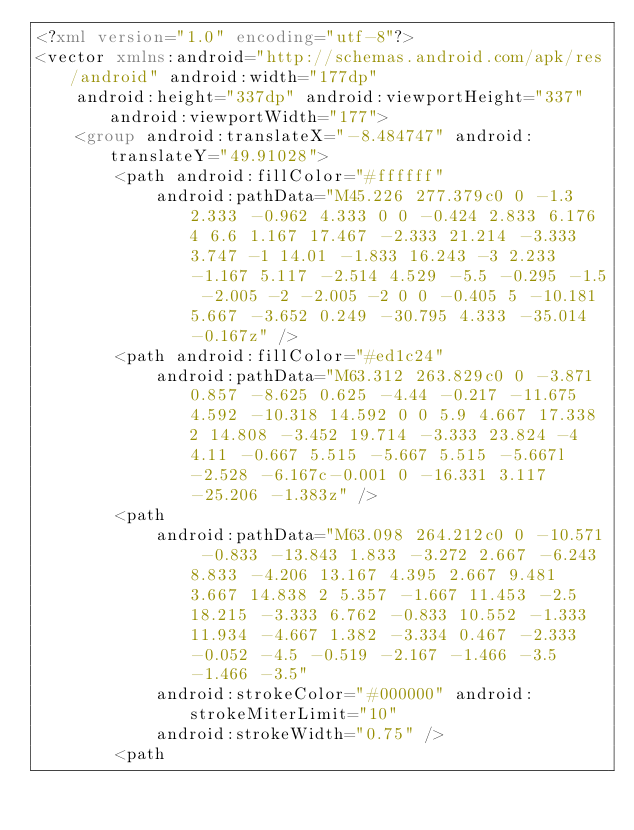<code> <loc_0><loc_0><loc_500><loc_500><_XML_><?xml version="1.0" encoding="utf-8"?>
<vector xmlns:android="http://schemas.android.com/apk/res/android" android:width="177dp"
    android:height="337dp" android:viewportHeight="337" android:viewportWidth="177">
    <group android:translateX="-8.484747" android:translateY="49.91028">
        <path android:fillColor="#ffffff"
            android:pathData="M45.226 277.379c0 0 -1.3 2.333 -0.962 4.333 0 0 -0.424 2.833 6.176 4 6.6 1.167 17.467 -2.333 21.214 -3.333 3.747 -1 14.01 -1.833 16.243 -3 2.233 -1.167 5.117 -2.514 4.529 -5.5 -0.295 -1.5 -2.005 -2 -2.005 -2 0 0 -0.405 5 -10.181 5.667 -3.652 0.249 -30.795 4.333 -35.014 -0.167z" />
        <path android:fillColor="#ed1c24"
            android:pathData="M63.312 263.829c0 0 -3.871 0.857 -8.625 0.625 -4.44 -0.217 -11.675 4.592 -10.318 14.592 0 0 5.9 4.667 17.338 2 14.808 -3.452 19.714 -3.333 23.824 -4 4.11 -0.667 5.515 -5.667 5.515 -5.667l-2.528 -6.167c-0.001 0 -16.331 3.117 -25.206 -1.383z" />
        <path
            android:pathData="M63.098 264.212c0 0 -10.571 -0.833 -13.843 1.833 -3.272 2.667 -6.243 8.833 -4.206 13.167 4.395 2.667 9.481 3.667 14.838 2 5.357 -1.667 11.453 -2.5 18.215 -3.333 6.762 -0.833 10.552 -1.333 11.934 -4.667 1.382 -3.334 0.467 -2.333 -0.052 -4.5 -0.519 -2.167 -1.466 -3.5 -1.466 -3.5"
            android:strokeColor="#000000" android:strokeMiterLimit="10"
            android:strokeWidth="0.75" />
        <path</code> 